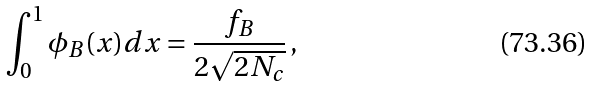Convert formula to latex. <formula><loc_0><loc_0><loc_500><loc_500>\int _ { 0 } ^ { 1 } \phi _ { B } ( x ) d x = \frac { f _ { B } } { 2 \sqrt { 2 N _ { c } } } \, ,</formula> 